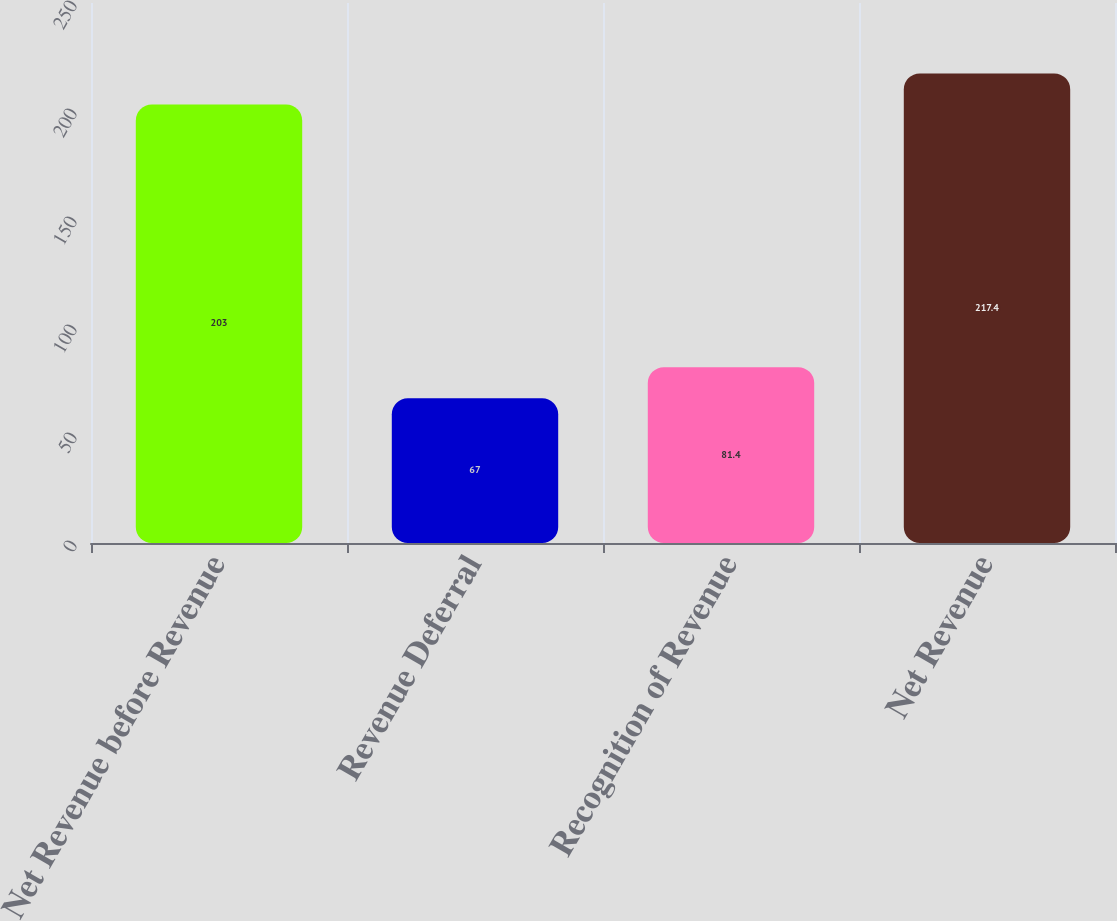Convert chart. <chart><loc_0><loc_0><loc_500><loc_500><bar_chart><fcel>Net Revenue before Revenue<fcel>Revenue Deferral<fcel>Recognition of Revenue<fcel>Net Revenue<nl><fcel>203<fcel>67<fcel>81.4<fcel>217.4<nl></chart> 